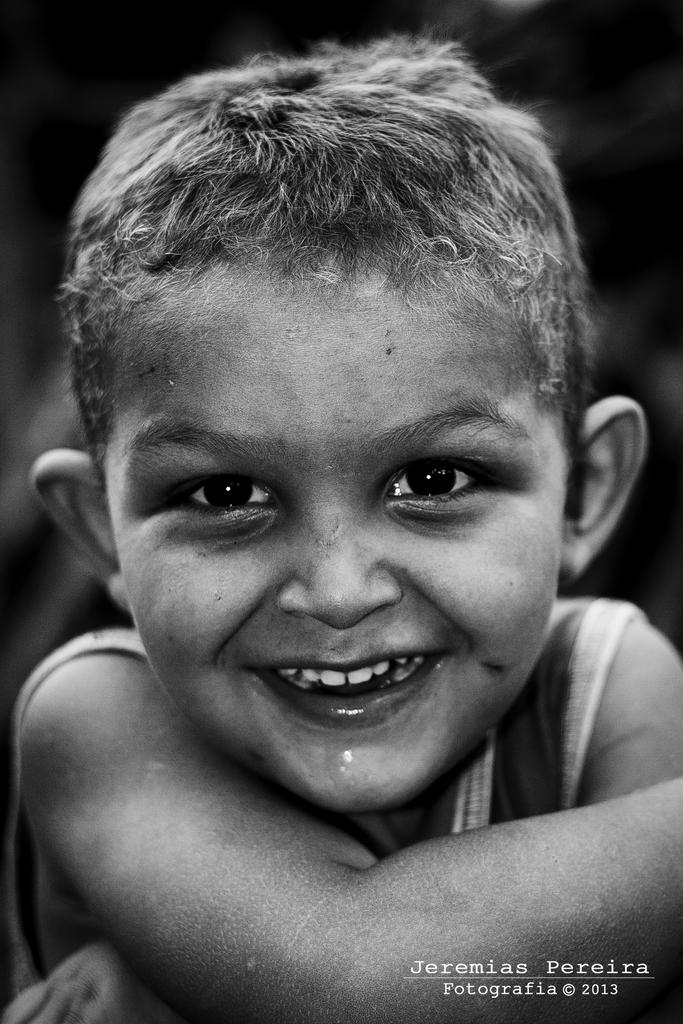What is the color scheme of the image? The image is black and white. Who is present in the image? There is a boy in the image. What is the boy's expression? The boy is smiling. What can be found at the bottom of the image? There is text and numbers at the bottom of the image. Is there any grass visible in the image? No, there is no grass present in the image. What type of heat can be felt coming from the boy in the image? There is no indication of heat or temperature in the image; it is a black and white photograph. 